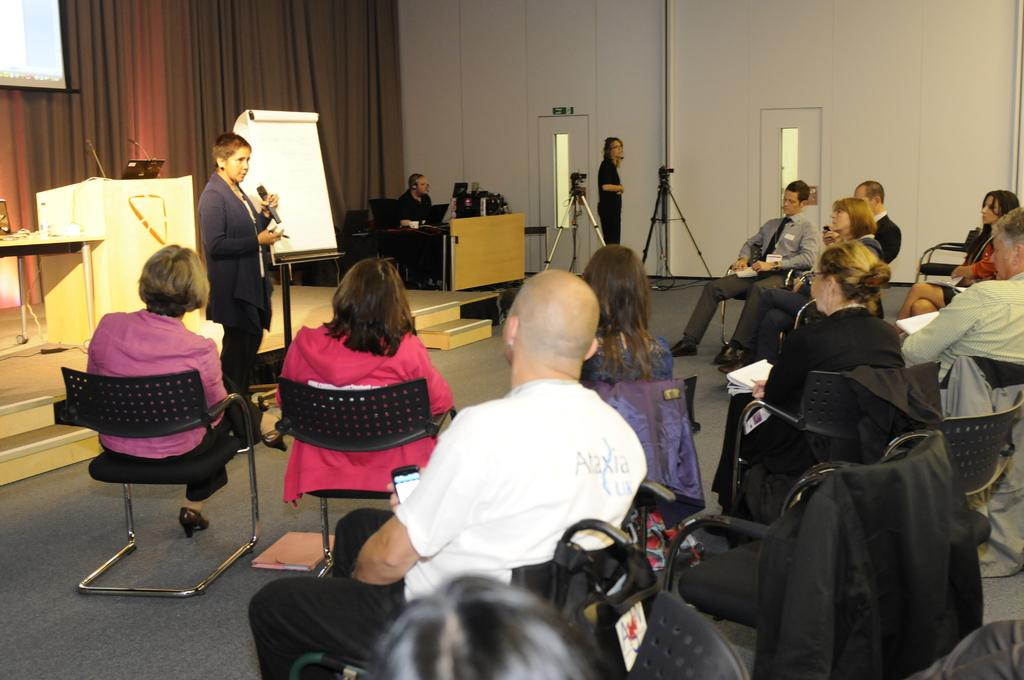What are the people in the image doing? The people in the image are sitting on chairs. What is the woman with the microphone doing? The woman is speaking on a microphone. What equipment is present in the image for recording or capturing images? There are two cameras on stands in the image. What type of volcano can be seen erupting in the background of the image? There is no volcano present in the image; it features people sitting on chairs, a woman speaking on a microphone, and cameras on stands. What is the woman's care routine for her breakfast in the image? There is no mention of breakfast or a care routine in the image; it focuses on people sitting on chairs, a woman speaking on a microphone, and cameras on stands. 